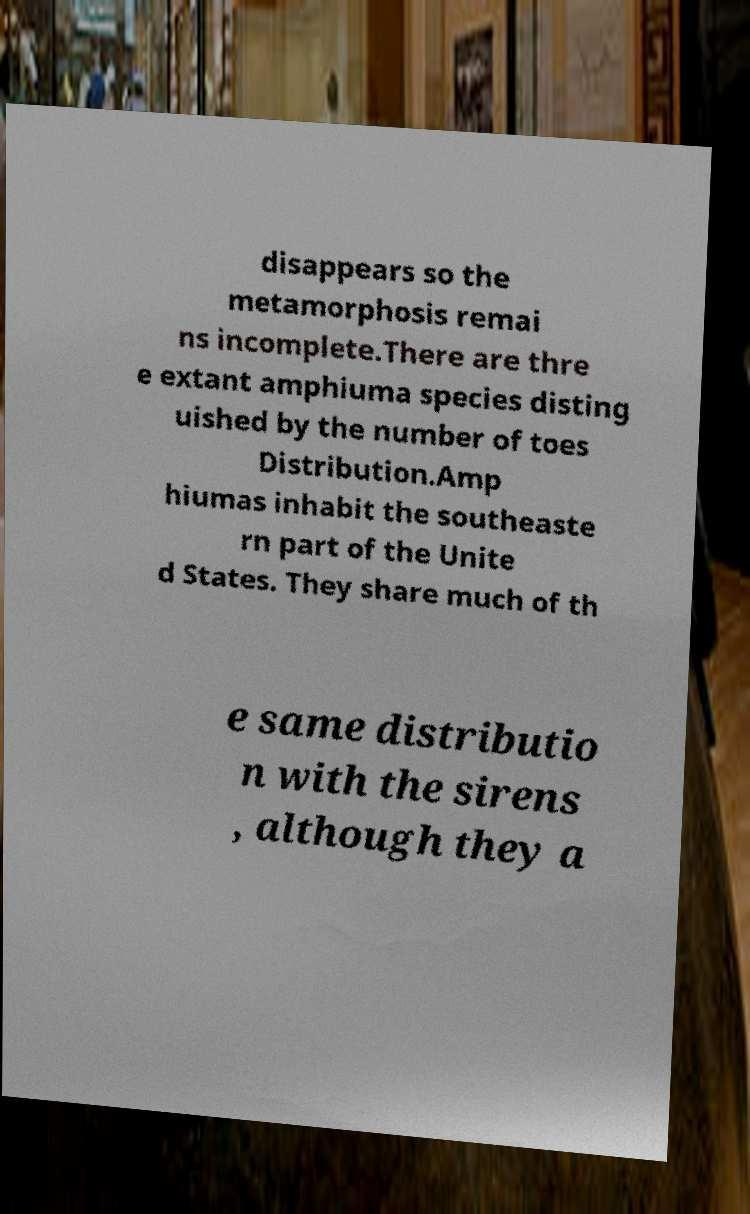Can you accurately transcribe the text from the provided image for me? disappears so the metamorphosis remai ns incomplete.There are thre e extant amphiuma species disting uished by the number of toes Distribution.Amp hiumas inhabit the southeaste rn part of the Unite d States. They share much of th e same distributio n with the sirens , although they a 